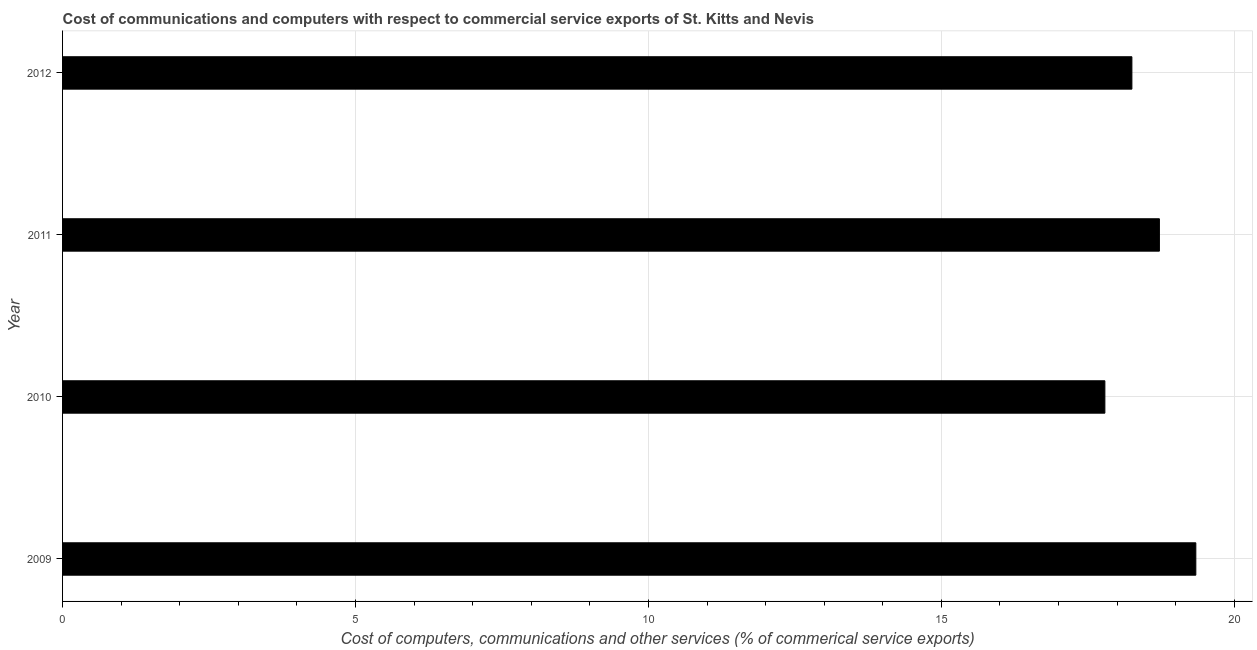What is the title of the graph?
Provide a short and direct response. Cost of communications and computers with respect to commercial service exports of St. Kitts and Nevis. What is the label or title of the X-axis?
Your answer should be very brief. Cost of computers, communications and other services (% of commerical service exports). What is the label or title of the Y-axis?
Your response must be concise. Year. What is the  computer and other services in 2009?
Make the answer very short. 19.34. Across all years, what is the maximum cost of communications?
Your response must be concise. 19.34. Across all years, what is the minimum  computer and other services?
Ensure brevity in your answer.  17.79. In which year was the cost of communications maximum?
Your answer should be compact. 2009. What is the sum of the  computer and other services?
Keep it short and to the point. 74.11. What is the difference between the  computer and other services in 2011 and 2012?
Your response must be concise. 0.47. What is the average cost of communications per year?
Make the answer very short. 18.53. What is the median cost of communications?
Give a very brief answer. 18.49. Do a majority of the years between 2010 and 2012 (inclusive) have cost of communications greater than 17 %?
Offer a very short reply. Yes. What is the ratio of the cost of communications in 2009 to that in 2012?
Your response must be concise. 1.06. Is the  computer and other services in 2009 less than that in 2011?
Your answer should be very brief. No. What is the difference between the highest and the second highest  computer and other services?
Give a very brief answer. 0.62. What is the difference between the highest and the lowest  computer and other services?
Give a very brief answer. 1.55. Are all the bars in the graph horizontal?
Your answer should be very brief. Yes. What is the Cost of computers, communications and other services (% of commerical service exports) of 2009?
Give a very brief answer. 19.34. What is the Cost of computers, communications and other services (% of commerical service exports) in 2010?
Ensure brevity in your answer.  17.79. What is the Cost of computers, communications and other services (% of commerical service exports) of 2011?
Offer a very short reply. 18.72. What is the Cost of computers, communications and other services (% of commerical service exports) in 2012?
Keep it short and to the point. 18.25. What is the difference between the Cost of computers, communications and other services (% of commerical service exports) in 2009 and 2010?
Keep it short and to the point. 1.55. What is the difference between the Cost of computers, communications and other services (% of commerical service exports) in 2009 and 2011?
Provide a succinct answer. 0.62. What is the difference between the Cost of computers, communications and other services (% of commerical service exports) in 2009 and 2012?
Your answer should be compact. 1.09. What is the difference between the Cost of computers, communications and other services (% of commerical service exports) in 2010 and 2011?
Your answer should be compact. -0.93. What is the difference between the Cost of computers, communications and other services (% of commerical service exports) in 2010 and 2012?
Make the answer very short. -0.46. What is the difference between the Cost of computers, communications and other services (% of commerical service exports) in 2011 and 2012?
Your response must be concise. 0.47. What is the ratio of the Cost of computers, communications and other services (% of commerical service exports) in 2009 to that in 2010?
Ensure brevity in your answer.  1.09. What is the ratio of the Cost of computers, communications and other services (% of commerical service exports) in 2009 to that in 2011?
Keep it short and to the point. 1.03. What is the ratio of the Cost of computers, communications and other services (% of commerical service exports) in 2009 to that in 2012?
Provide a succinct answer. 1.06. What is the ratio of the Cost of computers, communications and other services (% of commerical service exports) in 2010 to that in 2011?
Ensure brevity in your answer.  0.95. What is the ratio of the Cost of computers, communications and other services (% of commerical service exports) in 2010 to that in 2012?
Give a very brief answer. 0.97. What is the ratio of the Cost of computers, communications and other services (% of commerical service exports) in 2011 to that in 2012?
Your response must be concise. 1.03. 